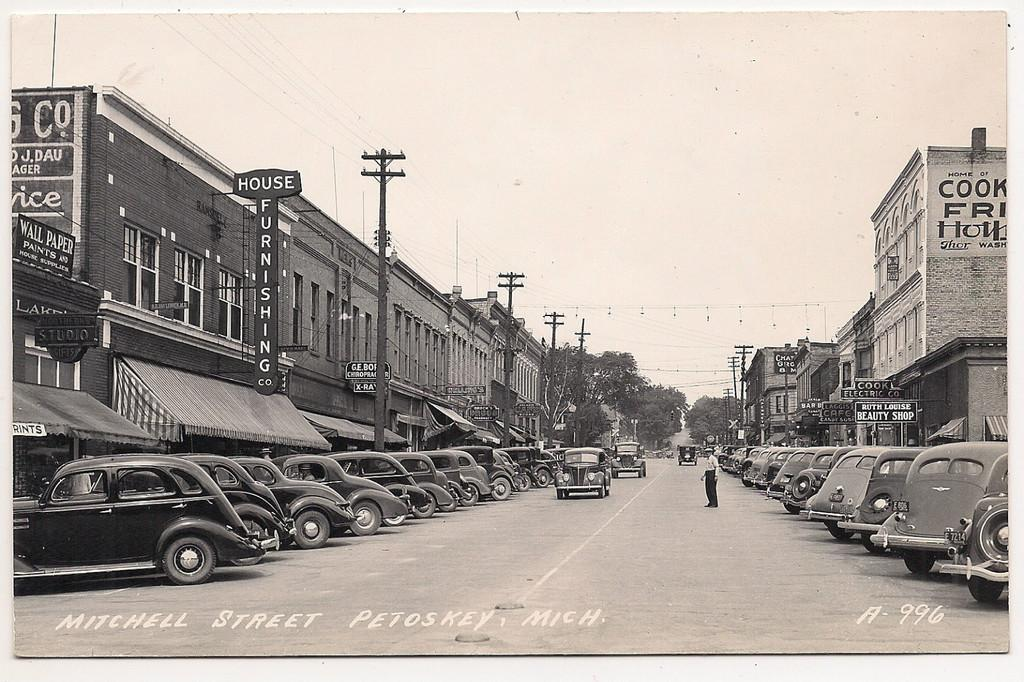What can be seen beside the road in the image? There are buildings beside the road in the image. What is parked in front of the buildings? There are cars parked in front of the buildings. Can you describe the person in the image? There is a person standing in the middle of the road. What type of crime is being committed by the mice in the image? There are no mice present in the image, so it is not possible to determine if any crime is being committed. 